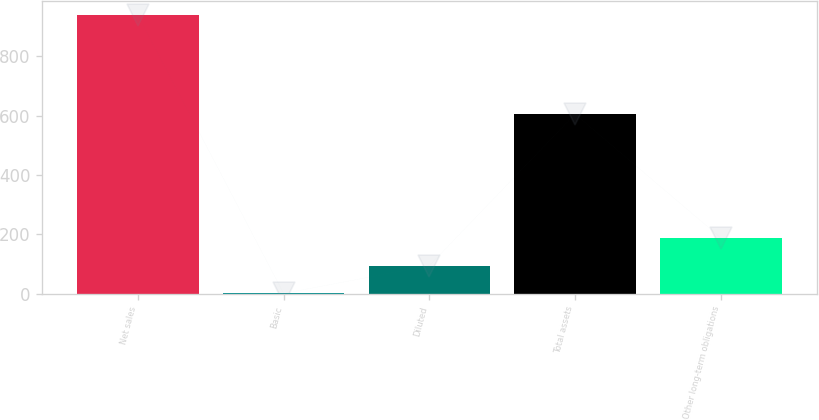Convert chart. <chart><loc_0><loc_0><loc_500><loc_500><bar_chart><fcel>Net sales<fcel>Basic<fcel>Diluted<fcel>Total assets<fcel>Other long-term obligations<nl><fcel>938.9<fcel>0.77<fcel>94.58<fcel>605.6<fcel>188.39<nl></chart> 